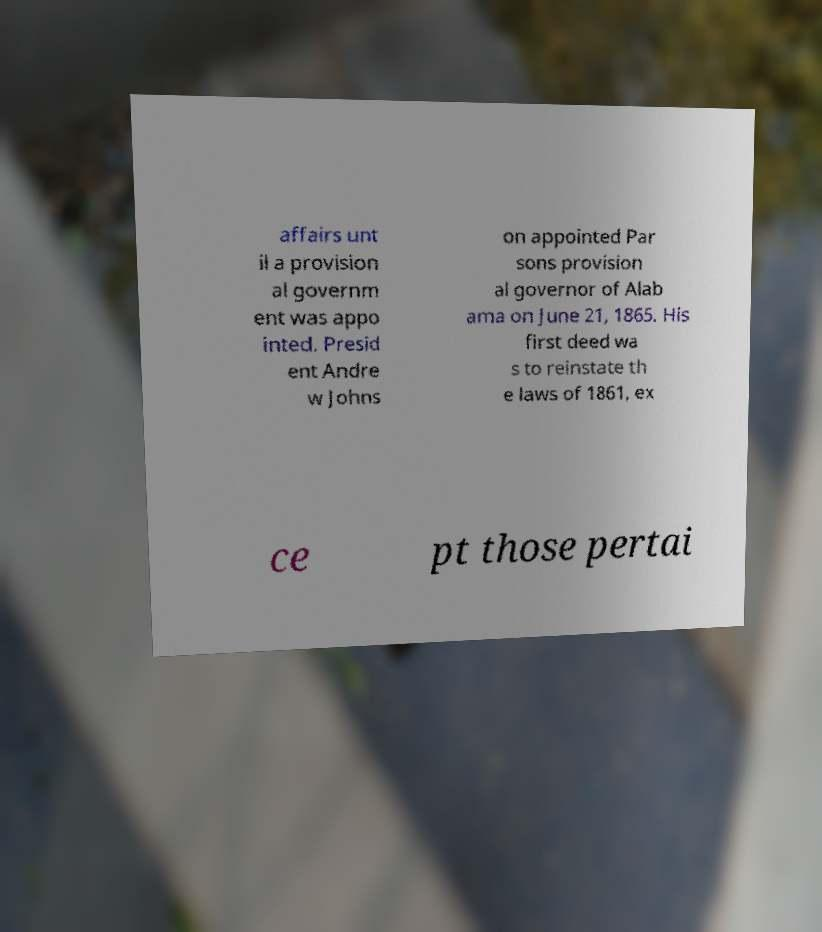What messages or text are displayed in this image? I need them in a readable, typed format. affairs unt il a provision al governm ent was appo inted. Presid ent Andre w Johns on appointed Par sons provision al governor of Alab ama on June 21, 1865. His first deed wa s to reinstate th e laws of 1861, ex ce pt those pertai 